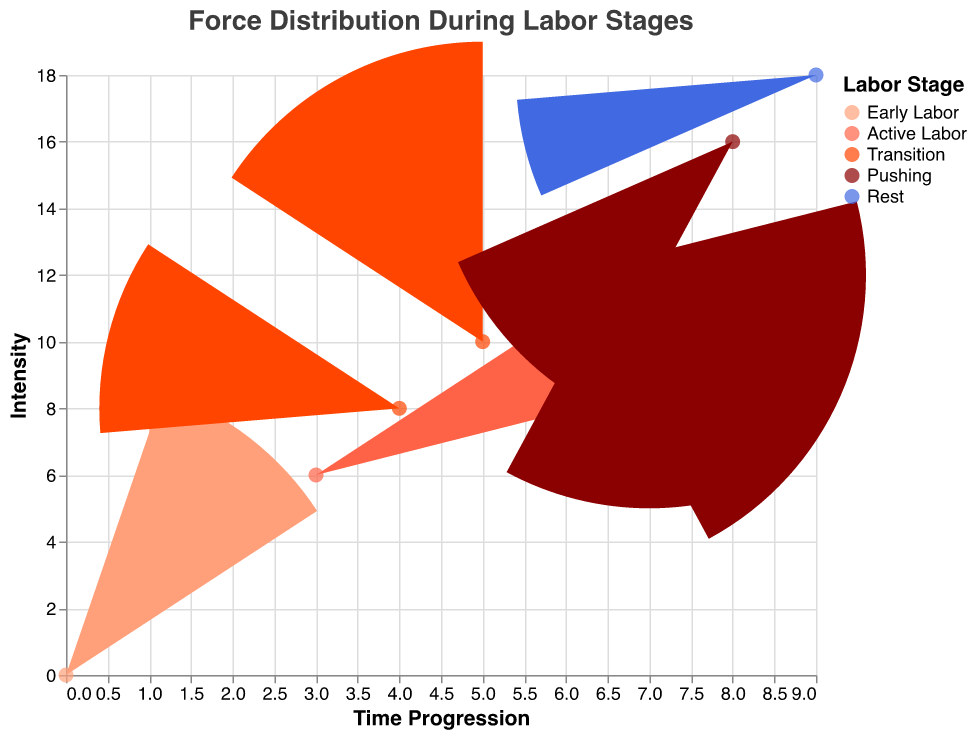What does the title of the figure indicate? The title is "Force Distribution During Labor Stages," which suggests that the figure shows how force distribution varies across different stages of labor.
Answer: "Force Distribution During Labor Stages" What are the axes titles of the figure? The x-axis is labeled "Time Progression," and the y-axis is labeled "Intensity," reflecting the movement through labor stages and the strength of contractions, respectively.
Answer: "Time Progression" and "Intensity" How many stages of labor are represented in the quiver plot? There are five stages of labor represented in the plot: Early Labor, Active Labor, Transition, Pushing, and Rest. This can be observed from the color legend.
Answer: Five Which stage of labor shows the highest intensity of contractions? The "Transition" stage shows the highest intensity with a y-value of 8 and 10, which is represented by points (4, 8) and (5, 10).
Answer: Transition Which direction does the contraction force primarily point to during the "Early Labor" stage? During "Early Labor," the contraction force primarily points in the left and upward direction, as shown by vectors with coordinates (0,0) pointing (-2,1) and (1,2) pointing (-1,2).
Answer: Left and upward What is the magnitude of the contraction force during the "Active Labor" stage at point (2,4)? At point (2,4) during "Active Labor," the magnitude of the contraction force is 3.0, as provided in the data.
Answer: 3.0 Compare the contraction force magnitude between the "Transition" stage and the "Pushing" stage at point (5,10) and (6,12), respectively. Which stage has a higher magnitude and by how much? In "Transition" stage at point (5,10), the magnitude is 5.00, and in the "Pushing" stage at point (6,12), the magnitude is also 5.00. The magnitudes are equal.
Answer: Equal What trend do you observe in the contraction forces during the "Pushing" stage? During the "Pushing" stage, the contraction forces have vectors pointing right and slightly upward, and the magnitude decreases progressively from 5.00 at (6,12) to 3.61 at (7,14) to 2.24 at (8,16).
Answer: Decreasing magnitude How does the contraction force change from "Transition" to "Rest" stage? Transition stage vectors show higher magnitudes (5.39 and 5.00) pointing right and significantly up, while Rest stage has the lowest magnitude (1.00) with the vector almost horizontal, indicating diminishing force intensity as labor progresses to rest.
Answer: Diminishes Where is the vector pointing during the "Rest" stage, and what is its magnitude? The vector during the "Rest" stage at point (9,18) points to the right (1,0) with the lowest magnitude of 1.00, indicating the least intense contraction.
Answer: Right and 1.00 